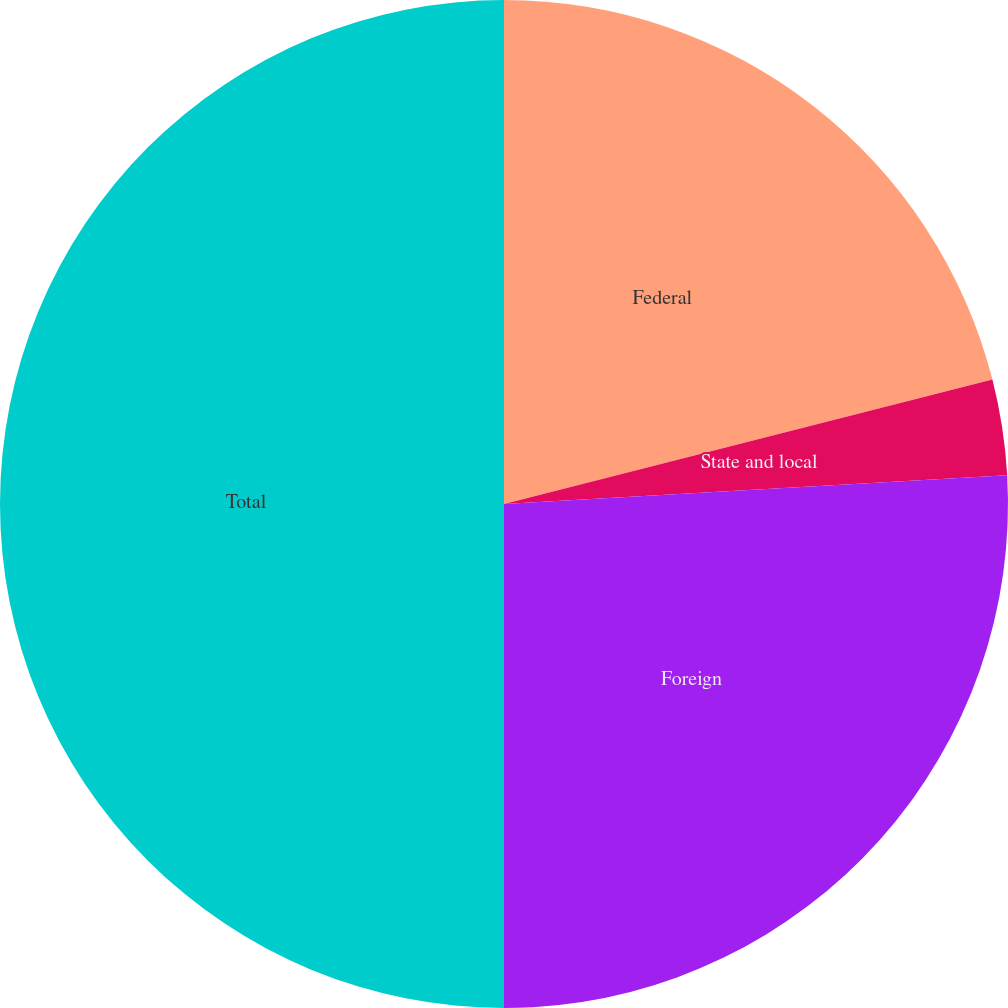<chart> <loc_0><loc_0><loc_500><loc_500><pie_chart><fcel>Federal<fcel>State and local<fcel>Foreign<fcel>Total<nl><fcel>21.03%<fcel>3.06%<fcel>25.91%<fcel>50.0%<nl></chart> 